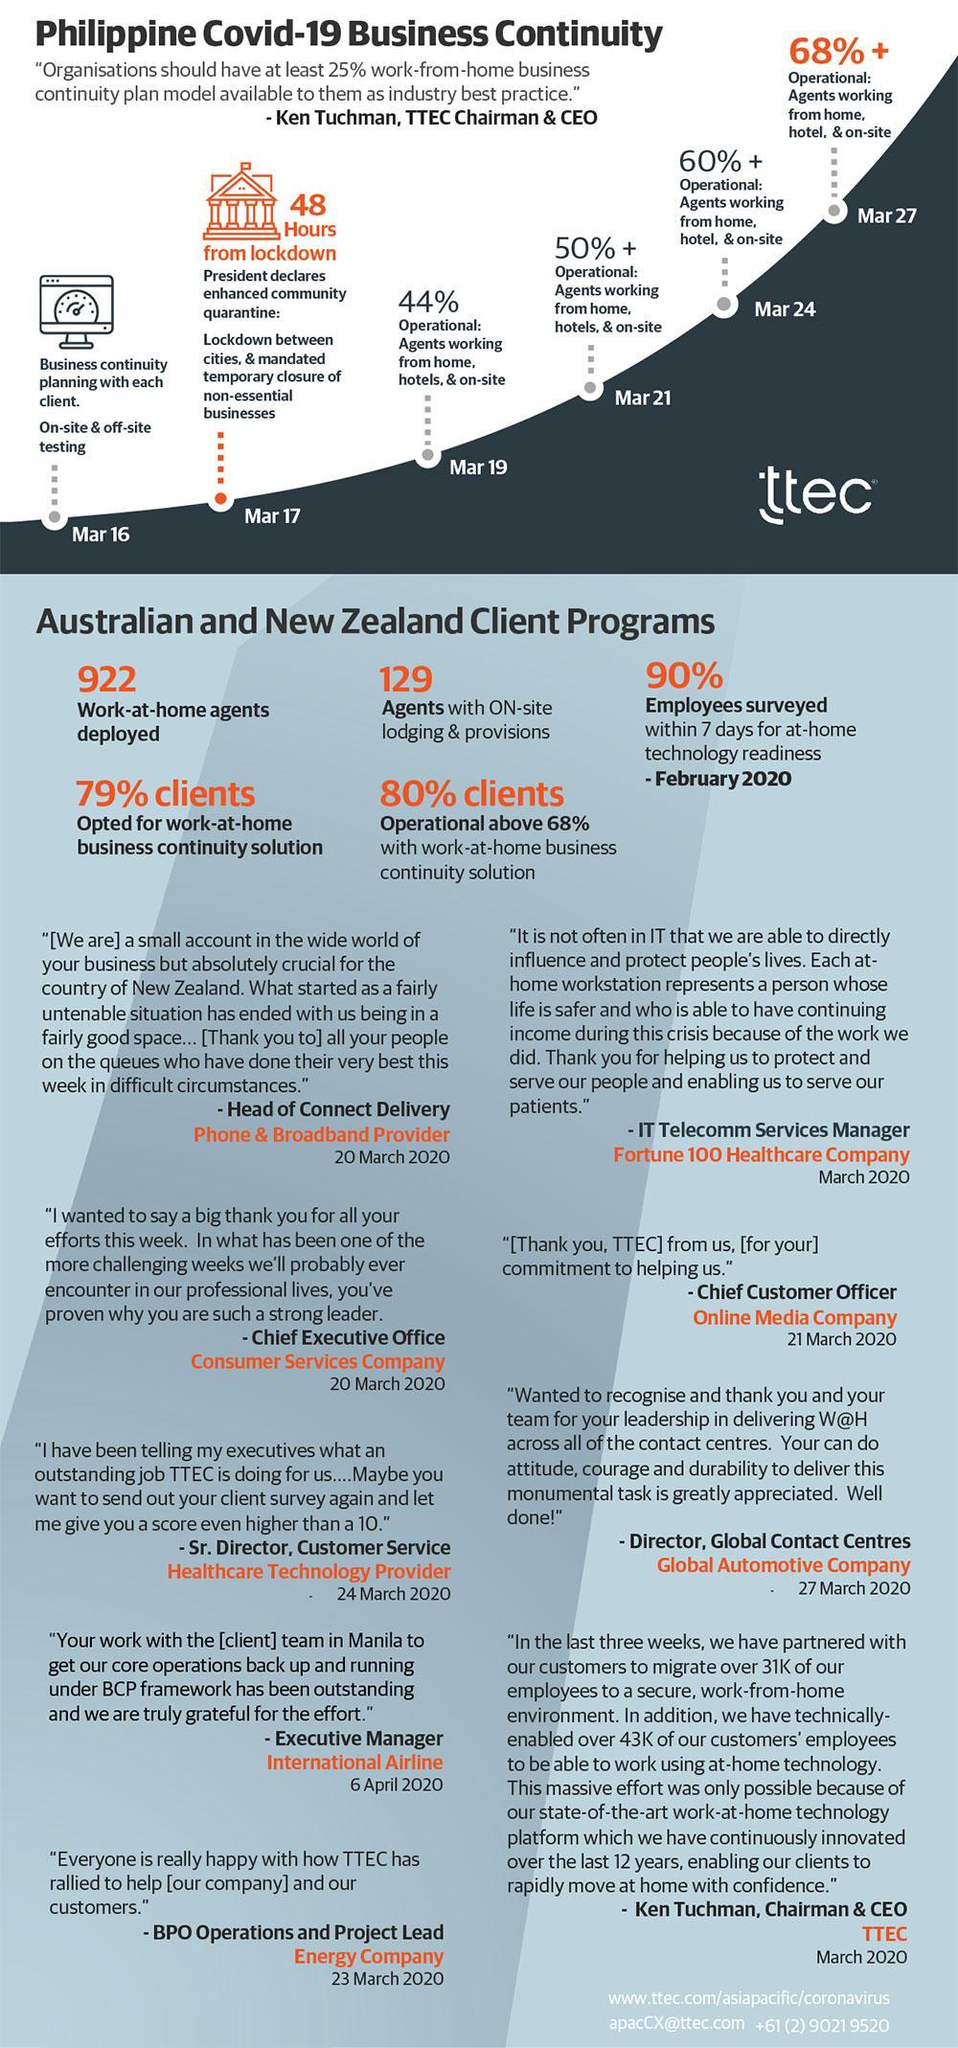How many work-at-home agents were deployed in the Australian & New Zealand Client Programs during COVID-19?
Answer the question with a short phrase. 922 What percentage of clients opted for work-at-home business continuity solution in the Philippines during COVID-19? 79% What percent of clients were operational above 68% with work-at-home business continuity solution in the Philippines during COVID-19? 80% What is the percent increase in agents working from home, hotel & on-site in the Philippines on March 27 during COVID-19? 68% What is the percent increase in agents working from home, hotel & on-site in the Philippines on March 21? 50% What is the percent increase in agents working from home, hotel & on-site in the Philippines on March 24? 60% When did the president declared mandated temporary closure of non-essential businesses in the Philippines? Mar 17 What percent of agents were provided with on-site lodging & provisions in the Australian & New Zealand Client Programs during COVID-19? 129 